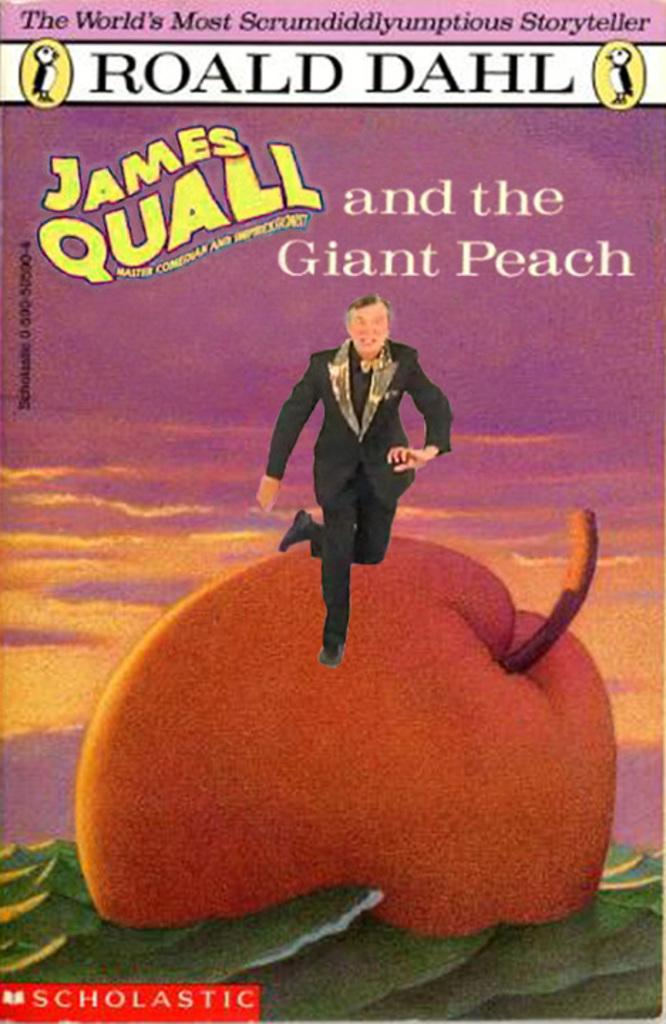What is present on the paper in the image? There is a fruit and a person depicted on the paper. What else can be seen on the paper? There is writing on the paper. What type of cup is being used to play in the field in the image? There is no cup or field present in the image; it only features a paper with a fruit, person, and writing. 